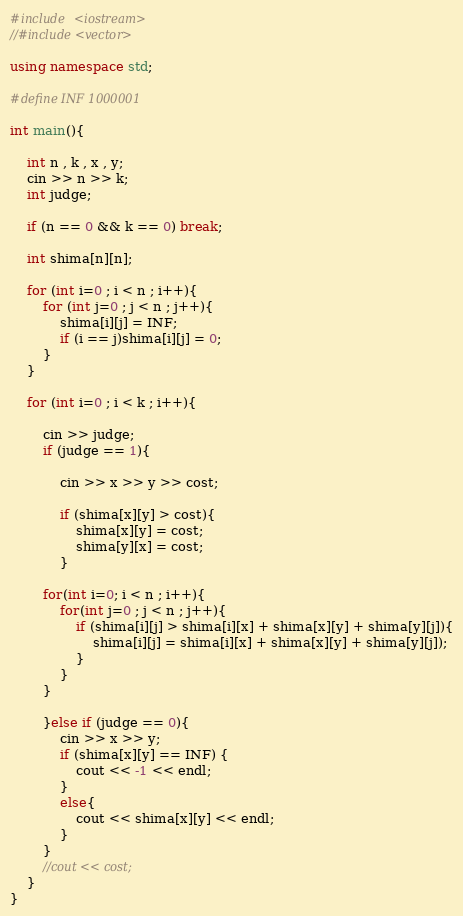Convert code to text. <code><loc_0><loc_0><loc_500><loc_500><_C++_>#include <iostream>
//#include <vector>

using namespace std;

#define INF 1000001 

int main(){

	int n , k , x , y;
	cin >> n >> k;
	int judge;

	if (n == 0 && k == 0) break;
	
	int shima[n][n];

	for (int i=0 ; i < n ; i++){
		for (int j=0 ; j < n ; j++){
			shima[i][j] = INF;
			if (i == j)shima[i][j] = 0;
 		}
	}

	for (int i=0 ; i < k ; i++){

		cin >> judge;
		if (judge == 1){

			cin >> x >> y >> cost;

			if (shima[x][y] > cost){
				shima[x][y] = cost;
				shima[y][x] = cost;
			}

		for(int i=0; i < n ; i++){
			for(int j=0 ; j < n ; j++){
				if (shima[i][j] > shima[i][x] + shima[x][y] + shima[y][j]){
					shima[i][j] = shima[i][x] + shima[x][y] + shima[y][j]);
				}
			}
		}	

		}else if (judge == 0){
			cin >> x >> y;
			if (shima[x][y] == INF) {
				cout << -1 << endl;
			}
			else{
				cout << shima[x][y] << endl;
			}
		}
		//cout << cost;
	}
}

</code> 